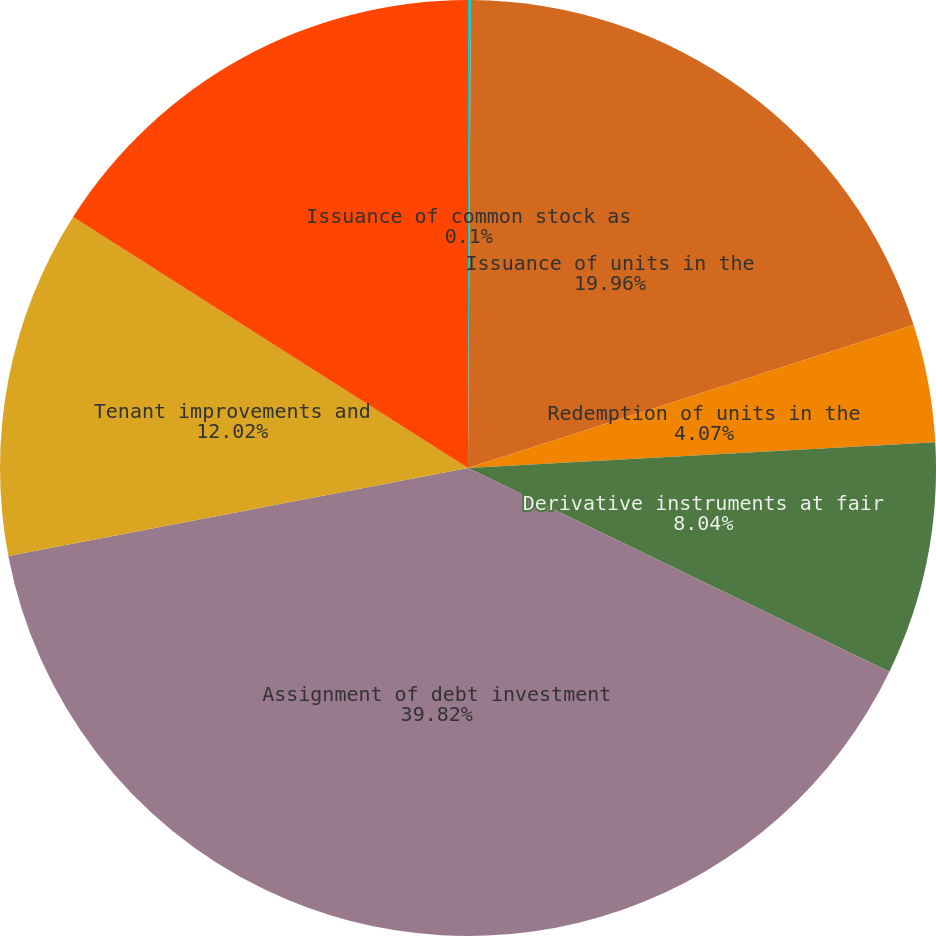Convert chart to OTSL. <chart><loc_0><loc_0><loc_500><loc_500><pie_chart><fcel>Issuance of common stock as<fcel>Issuance of units in the<fcel>Redemption of units in the<fcel>Derivative instruments at fair<fcel>Assignment of debt investment<fcel>Tenant improvements and<fcel>Fair value adjustment to<nl><fcel>0.1%<fcel>19.96%<fcel>4.07%<fcel>8.04%<fcel>39.83%<fcel>12.02%<fcel>15.99%<nl></chart> 